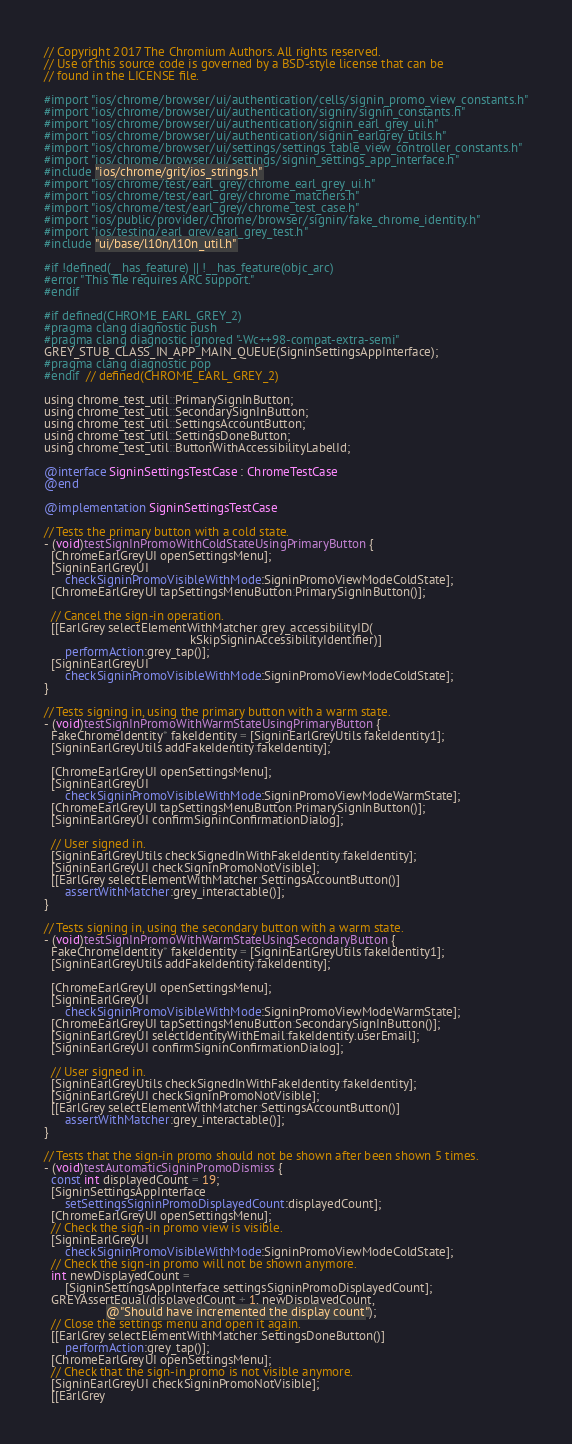Convert code to text. <code><loc_0><loc_0><loc_500><loc_500><_ObjectiveC_>// Copyright 2017 The Chromium Authors. All rights reserved.
// Use of this source code is governed by a BSD-style license that can be
// found in the LICENSE file.

#import "ios/chrome/browser/ui/authentication/cells/signin_promo_view_constants.h"
#import "ios/chrome/browser/ui/authentication/signin/signin_constants.h"
#import "ios/chrome/browser/ui/authentication/signin_earl_grey_ui.h"
#import "ios/chrome/browser/ui/authentication/signin_earlgrey_utils.h"
#import "ios/chrome/browser/ui/settings/settings_table_view_controller_constants.h"
#import "ios/chrome/browser/ui/settings/signin_settings_app_interface.h"
#include "ios/chrome/grit/ios_strings.h"
#import "ios/chrome/test/earl_grey/chrome_earl_grey_ui.h"
#import "ios/chrome/test/earl_grey/chrome_matchers.h"
#import "ios/chrome/test/earl_grey/chrome_test_case.h"
#import "ios/public/provider/chrome/browser/signin/fake_chrome_identity.h"
#import "ios/testing/earl_grey/earl_grey_test.h"
#include "ui/base/l10n/l10n_util.h"

#if !defined(__has_feature) || !__has_feature(objc_arc)
#error "This file requires ARC support."
#endif

#if defined(CHROME_EARL_GREY_2)
#pragma clang diagnostic push
#pragma clang diagnostic ignored "-Wc++98-compat-extra-semi"
GREY_STUB_CLASS_IN_APP_MAIN_QUEUE(SigninSettingsAppInterface);
#pragma clang diagnostic pop
#endif  // defined(CHROME_EARL_GREY_2)

using chrome_test_util::PrimarySignInButton;
using chrome_test_util::SecondarySignInButton;
using chrome_test_util::SettingsAccountButton;
using chrome_test_util::SettingsDoneButton;
using chrome_test_util::ButtonWithAccessibilityLabelId;

@interface SigninSettingsTestCase : ChromeTestCase
@end

@implementation SigninSettingsTestCase

// Tests the primary button with a cold state.
- (void)testSignInPromoWithColdStateUsingPrimaryButton {
  [ChromeEarlGreyUI openSettingsMenu];
  [SigninEarlGreyUI
      checkSigninPromoVisibleWithMode:SigninPromoViewModeColdState];
  [ChromeEarlGreyUI tapSettingsMenuButton:PrimarySignInButton()];

  // Cancel the sign-in operation.
  [[EarlGrey selectElementWithMatcher:grey_accessibilityID(
                                          kSkipSigninAccessibilityIdentifier)]
      performAction:grey_tap()];
  [SigninEarlGreyUI
      checkSigninPromoVisibleWithMode:SigninPromoViewModeColdState];
}

// Tests signing in, using the primary button with a warm state.
- (void)testSignInPromoWithWarmStateUsingPrimaryButton {
  FakeChromeIdentity* fakeIdentity = [SigninEarlGreyUtils fakeIdentity1];
  [SigninEarlGreyUtils addFakeIdentity:fakeIdentity];

  [ChromeEarlGreyUI openSettingsMenu];
  [SigninEarlGreyUI
      checkSigninPromoVisibleWithMode:SigninPromoViewModeWarmState];
  [ChromeEarlGreyUI tapSettingsMenuButton:PrimarySignInButton()];
  [SigninEarlGreyUI confirmSigninConfirmationDialog];

  // User signed in.
  [SigninEarlGreyUtils checkSignedInWithFakeIdentity:fakeIdentity];
  [SigninEarlGreyUI checkSigninPromoNotVisible];
  [[EarlGrey selectElementWithMatcher:SettingsAccountButton()]
      assertWithMatcher:grey_interactable()];
}

// Tests signing in, using the secondary button with a warm state.
- (void)testSignInPromoWithWarmStateUsingSecondaryButton {
  FakeChromeIdentity* fakeIdentity = [SigninEarlGreyUtils fakeIdentity1];
  [SigninEarlGreyUtils addFakeIdentity:fakeIdentity];

  [ChromeEarlGreyUI openSettingsMenu];
  [SigninEarlGreyUI
      checkSigninPromoVisibleWithMode:SigninPromoViewModeWarmState];
  [ChromeEarlGreyUI tapSettingsMenuButton:SecondarySignInButton()];
  [SigninEarlGreyUI selectIdentityWithEmail:fakeIdentity.userEmail];
  [SigninEarlGreyUI confirmSigninConfirmationDialog];

  // User signed in.
  [SigninEarlGreyUtils checkSignedInWithFakeIdentity:fakeIdentity];
  [SigninEarlGreyUI checkSigninPromoNotVisible];
  [[EarlGrey selectElementWithMatcher:SettingsAccountButton()]
      assertWithMatcher:grey_interactable()];
}

// Tests that the sign-in promo should not be shown after been shown 5 times.
- (void)testAutomaticSigninPromoDismiss {
  const int displayedCount = 19;
  [SigninSettingsAppInterface
      setSettingsSigninPromoDisplayedCount:displayedCount];
  [ChromeEarlGreyUI openSettingsMenu];
  // Check the sign-in promo view is visible.
  [SigninEarlGreyUI
      checkSigninPromoVisibleWithMode:SigninPromoViewModeColdState];
  // Check the sign-in promo will not be shown anymore.
  int newDisplayedCount =
      [SigninSettingsAppInterface settingsSigninPromoDisplayedCount];
  GREYAssertEqual(displayedCount + 1, newDisplayedCount,
                  @"Should have incremented the display count");
  // Close the settings menu and open it again.
  [[EarlGrey selectElementWithMatcher:SettingsDoneButton()]
      performAction:grey_tap()];
  [ChromeEarlGreyUI openSettingsMenu];
  // Check that the sign-in promo is not visible anymore.
  [SigninEarlGreyUI checkSigninPromoNotVisible];
  [[EarlGrey</code> 